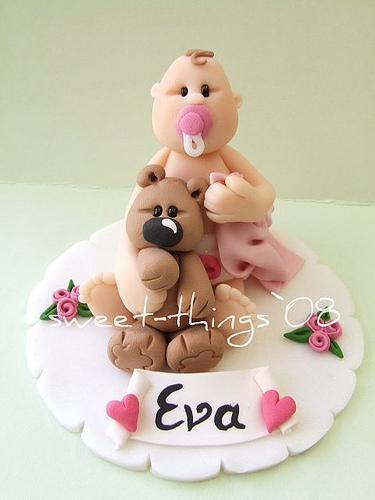Is the statement "The teddy bear is adjacent to the cake." accurate regarding the image?
Answer yes or no. No. Is "The teddy bear is part of the cake." an appropriate description for the image?
Answer yes or no. Yes. 